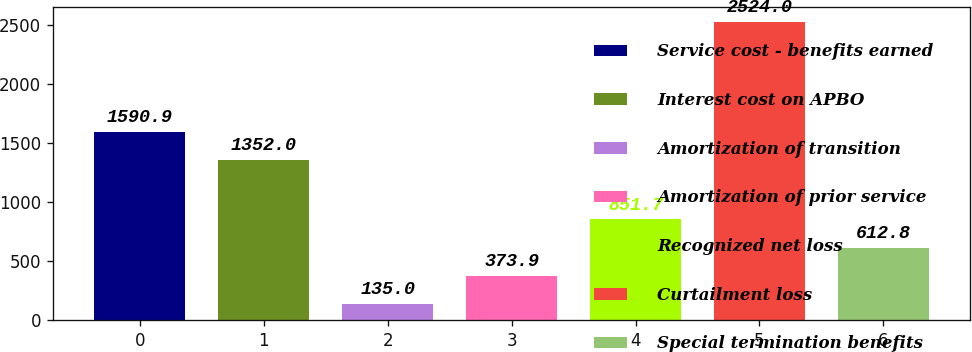Convert chart to OTSL. <chart><loc_0><loc_0><loc_500><loc_500><bar_chart><fcel>Service cost - benefits earned<fcel>Interest cost on APBO<fcel>Amortization of transition<fcel>Amortization of prior service<fcel>Recognized net loss<fcel>Curtailment loss<fcel>Special termination benefits<nl><fcel>1590.9<fcel>1352<fcel>135<fcel>373.9<fcel>851.7<fcel>2524<fcel>612.8<nl></chart> 